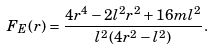<formula> <loc_0><loc_0><loc_500><loc_500>F _ { E } ( r ) = \frac { 4 r ^ { 4 } - 2 l ^ { 2 } r ^ { 2 } + 1 6 m l ^ { 2 } } { l ^ { 2 } ( 4 r ^ { 2 } - l ^ { 2 } ) } .</formula> 